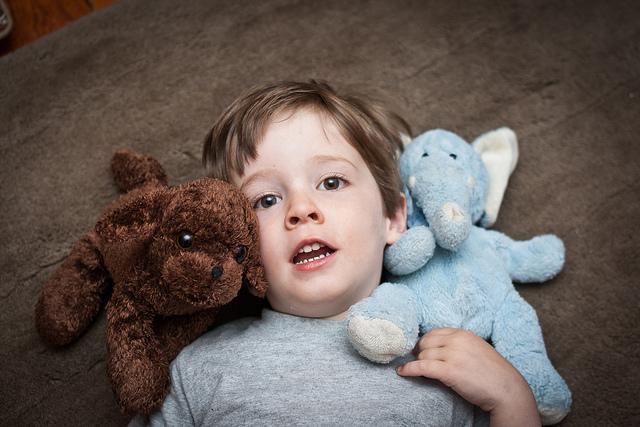How many skateboards are there?
Give a very brief answer. 0. 